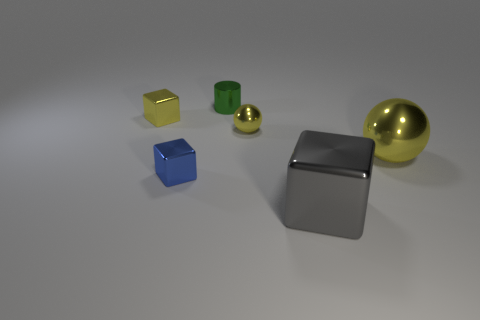The object behind the yellow object that is on the left side of the cylinder is what shape?
Offer a very short reply. Cylinder. Is there anything else of the same color as the small shiny cylinder?
Offer a terse response. No. Is there any other thing that is the same size as the blue cube?
Keep it short and to the point. Yes. What number of things are either cyan rubber balls or tiny metallic things?
Provide a short and direct response. 4. Is there a gray thing that has the same size as the blue shiny block?
Provide a succinct answer. No. There is a blue object; what shape is it?
Your answer should be compact. Cube. Are there more blue metallic cubes behind the blue metallic block than big gray objects that are behind the tiny green metal object?
Your response must be concise. No. Is the color of the tiny shiny block behind the blue thing the same as the ball that is behind the large yellow sphere?
Your answer should be compact. Yes. There is a yellow metallic thing that is the same size as the yellow cube; what is its shape?
Make the answer very short. Sphere. Is there another thing of the same shape as the large gray thing?
Make the answer very short. Yes. 